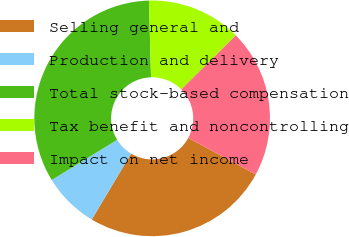Convert chart to OTSL. <chart><loc_0><loc_0><loc_500><loc_500><pie_chart><fcel>Selling general and<fcel>Production and delivery<fcel>Total stock-based compensation<fcel>Tax benefit and noncontrolling<fcel>Impact on net income<nl><fcel>25.67%<fcel>7.67%<fcel>33.33%<fcel>13.0%<fcel>20.33%<nl></chart> 